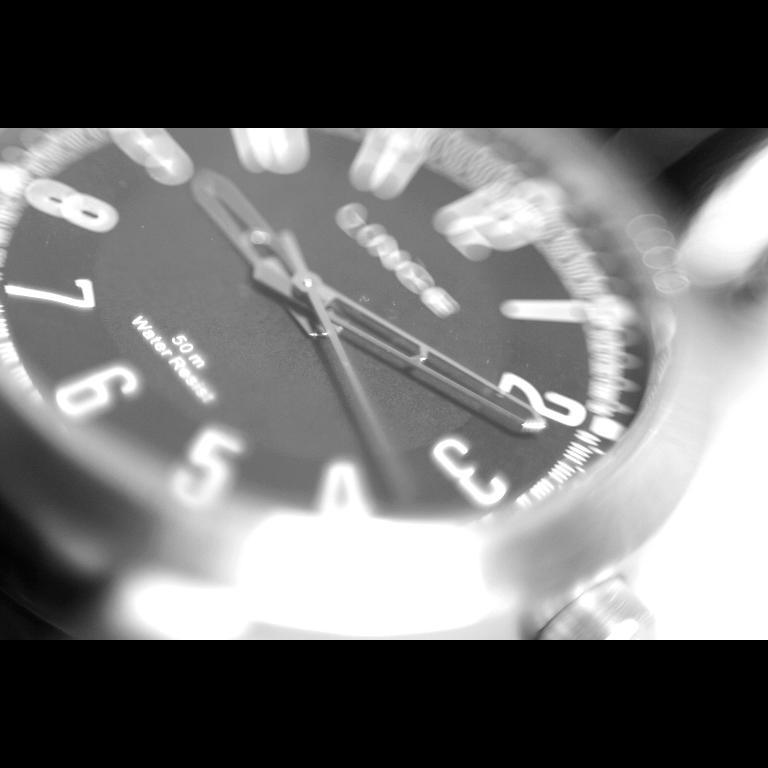About what time is it?
Make the answer very short. 9:11. 